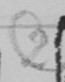Please provide the text content of this handwritten line. ( 2 ) 